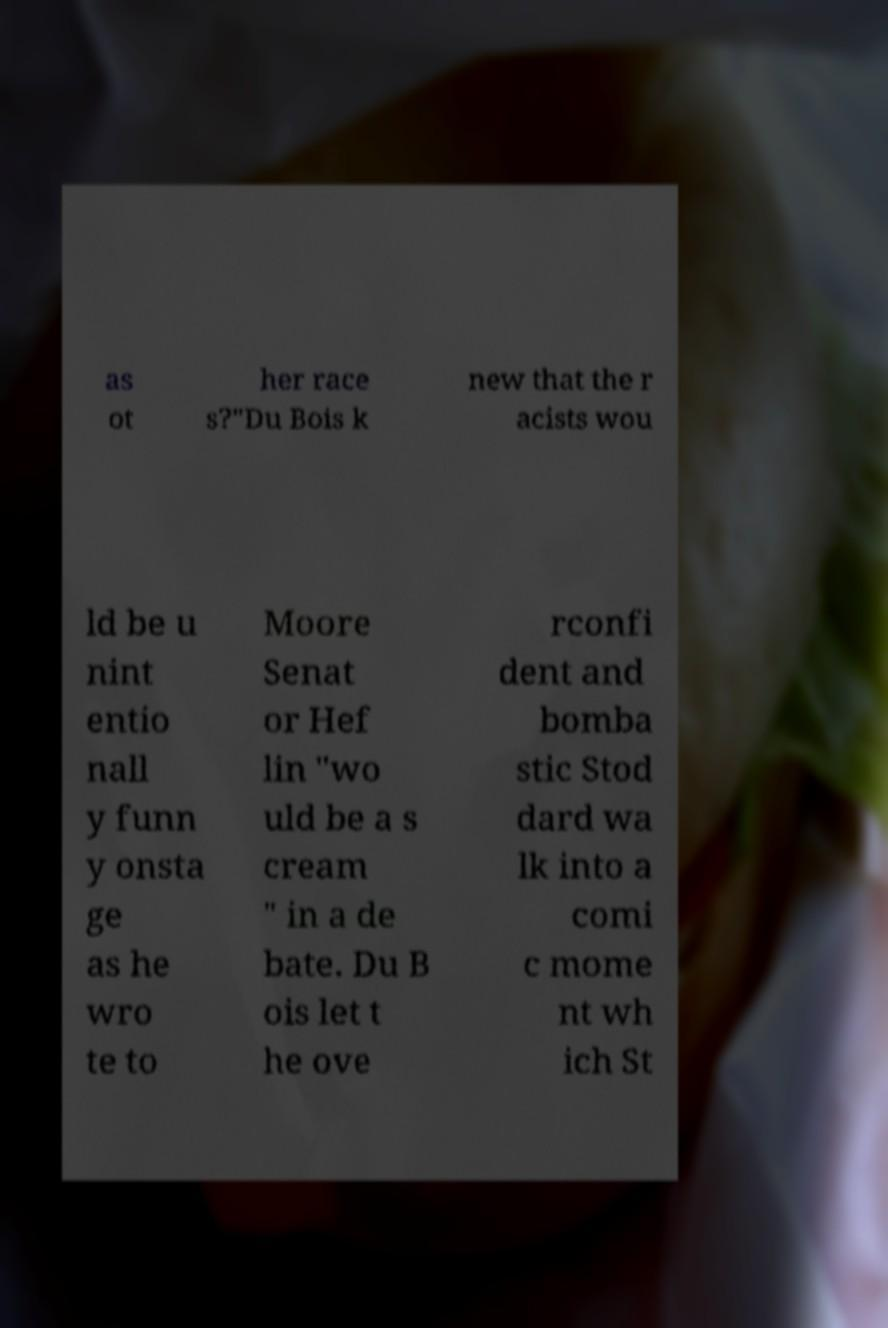There's text embedded in this image that I need extracted. Can you transcribe it verbatim? as ot her race s?"Du Bois k new that the r acists wou ld be u nint entio nall y funn y onsta ge as he wro te to Moore Senat or Hef lin "wo uld be a s cream " in a de bate. Du B ois let t he ove rconfi dent and bomba stic Stod dard wa lk into a comi c mome nt wh ich St 